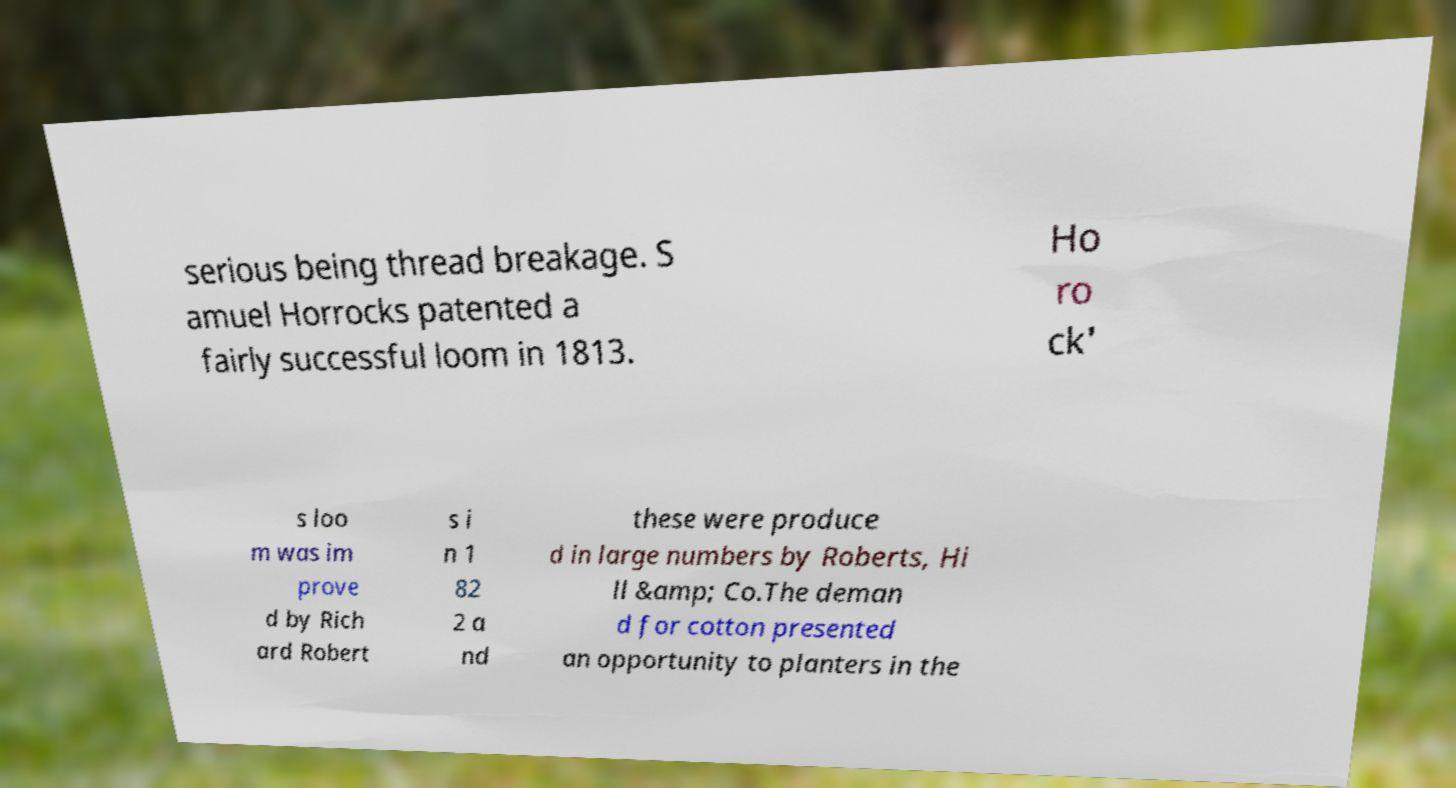For documentation purposes, I need the text within this image transcribed. Could you provide that? serious being thread breakage. S amuel Horrocks patented a fairly successful loom in 1813. Ho ro ck' s loo m was im prove d by Rich ard Robert s i n 1 82 2 a nd these were produce d in large numbers by Roberts, Hi ll &amp; Co.The deman d for cotton presented an opportunity to planters in the 